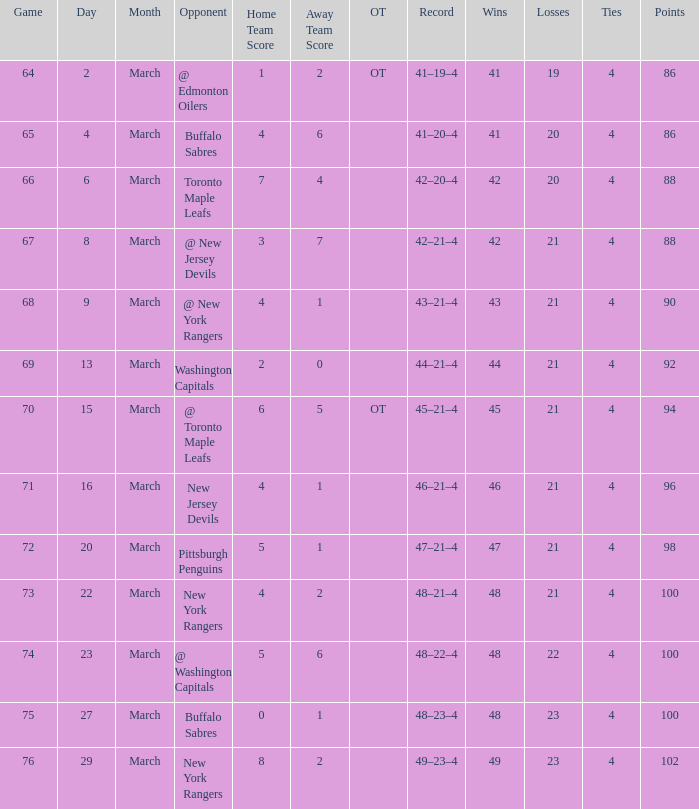Which march has the smallest position that has a score of 5–6, and points below 100? None. 